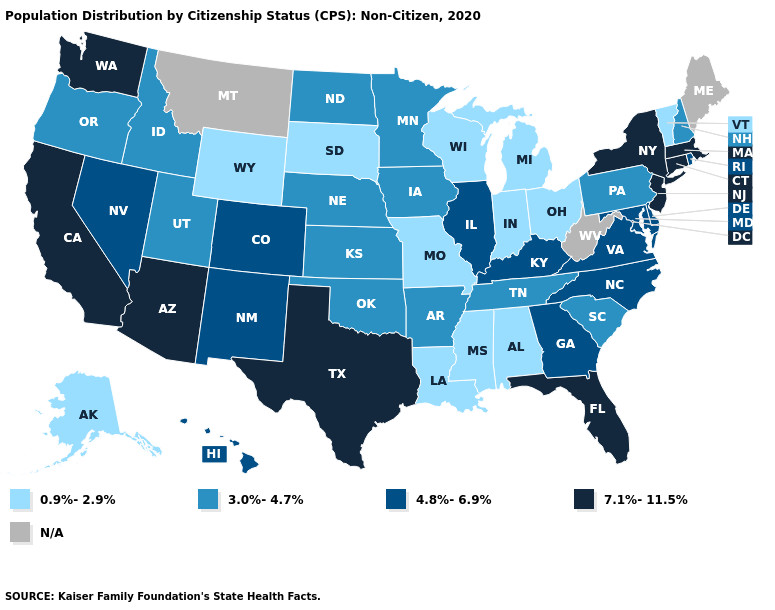What is the value of New Mexico?
Write a very short answer. 4.8%-6.9%. Name the states that have a value in the range 4.8%-6.9%?
Quick response, please. Colorado, Delaware, Georgia, Hawaii, Illinois, Kentucky, Maryland, Nevada, New Mexico, North Carolina, Rhode Island, Virginia. Does the map have missing data?
Quick response, please. Yes. What is the value of North Carolina?
Give a very brief answer. 4.8%-6.9%. What is the highest value in states that border Oregon?
Quick response, please. 7.1%-11.5%. What is the value of North Carolina?
Answer briefly. 4.8%-6.9%. What is the highest value in the Northeast ?
Write a very short answer. 7.1%-11.5%. Among the states that border North Carolina , does Georgia have the highest value?
Quick response, please. Yes. What is the highest value in the MidWest ?
Give a very brief answer. 4.8%-6.9%. What is the value of Massachusetts?
Write a very short answer. 7.1%-11.5%. What is the value of Pennsylvania?
Write a very short answer. 3.0%-4.7%. Does Michigan have the lowest value in the USA?
Concise answer only. Yes. Which states have the lowest value in the USA?
Short answer required. Alabama, Alaska, Indiana, Louisiana, Michigan, Mississippi, Missouri, Ohio, South Dakota, Vermont, Wisconsin, Wyoming. 